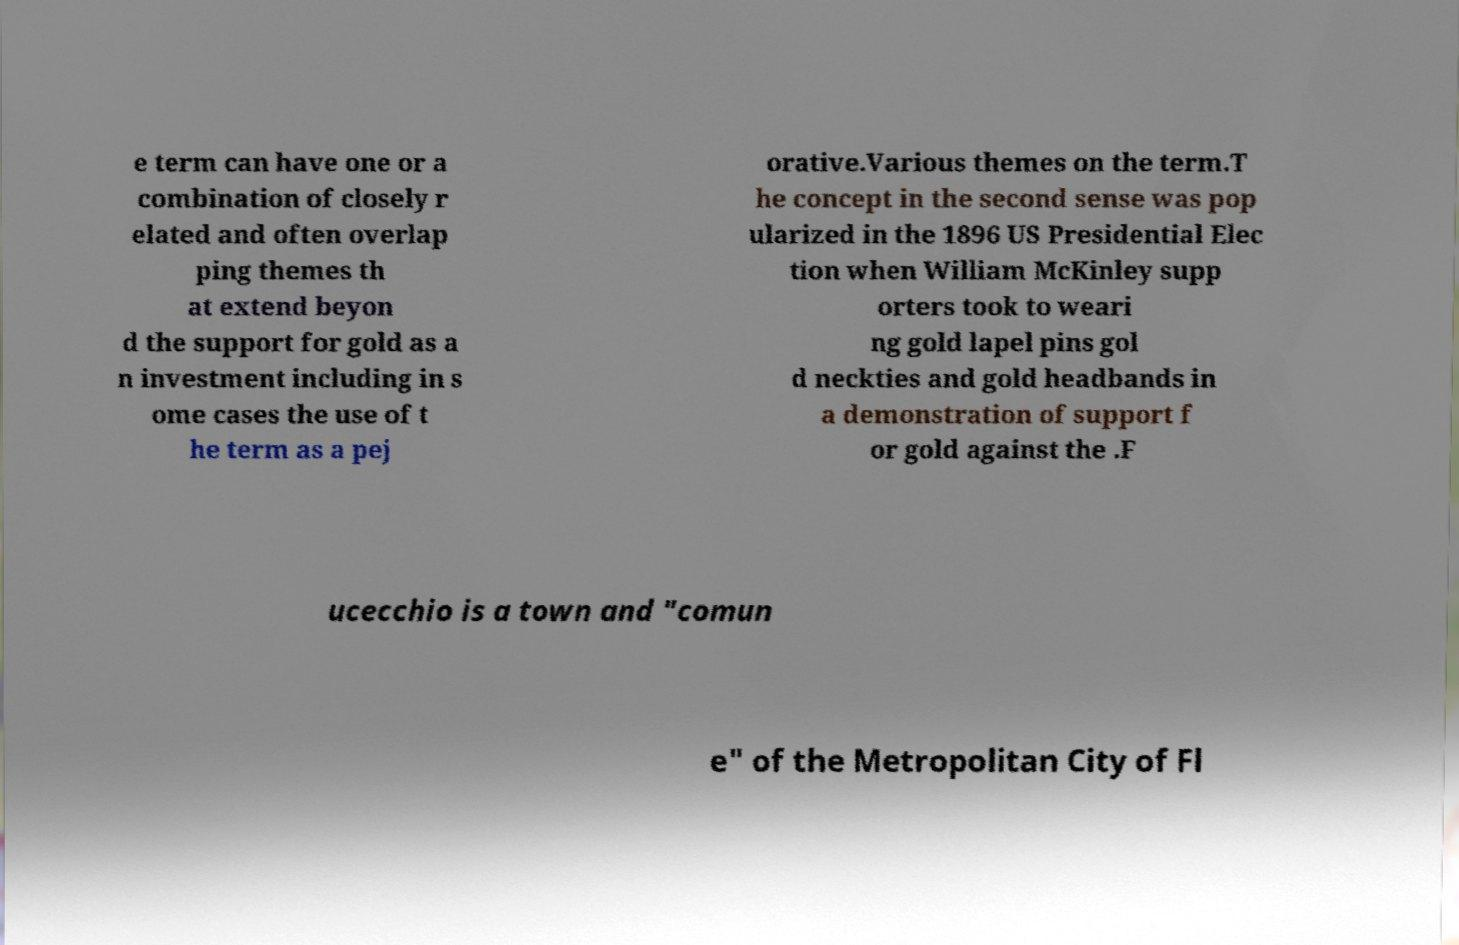Could you extract and type out the text from this image? e term can have one or a combination of closely r elated and often overlap ping themes th at extend beyon d the support for gold as a n investment including in s ome cases the use of t he term as a pej orative.Various themes on the term.T he concept in the second sense was pop ularized in the 1896 US Presidential Elec tion when William McKinley supp orters took to weari ng gold lapel pins gol d neckties and gold headbands in a demonstration of support f or gold against the .F ucecchio is a town and "comun e" of the Metropolitan City of Fl 